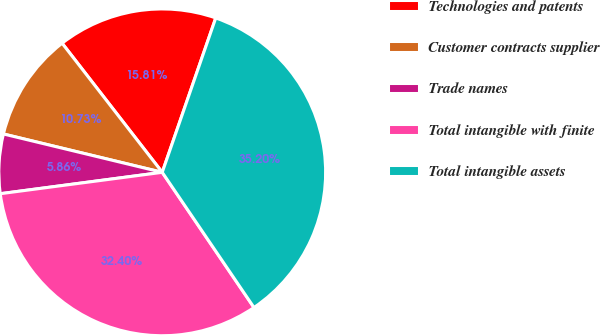Convert chart to OTSL. <chart><loc_0><loc_0><loc_500><loc_500><pie_chart><fcel>Technologies and patents<fcel>Customer contracts supplier<fcel>Trade names<fcel>Total intangible with finite<fcel>Total intangible assets<nl><fcel>15.81%<fcel>10.73%<fcel>5.86%<fcel>32.4%<fcel>35.2%<nl></chart> 